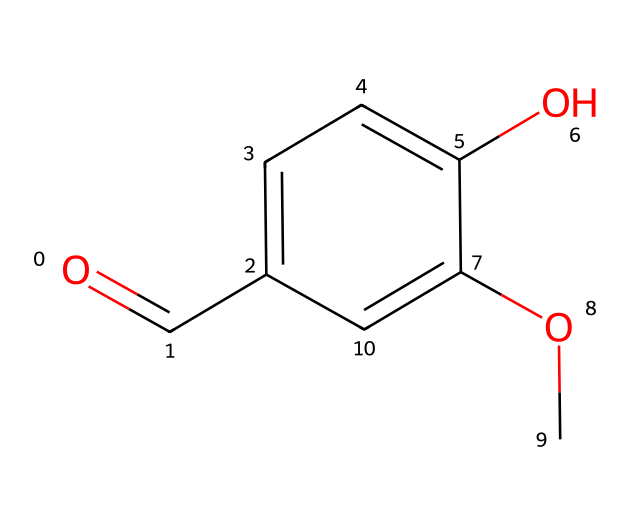What is the name of this chemical? The chemical structure provided represents vanillin, which is a compound commonly associated with the flavor of vanilla. The combination of carbon, oxygen, and hydroxyl functional groups is characteristic of vanillin.
Answer: vanillin How many carbon atoms are in vanillin? By analyzing the SMILES representation, we can count the number of carbon atoms. The structure shows six carbon atoms in the aromatic ring and the carbonyl carbon, totaling seven.
Answer: 7 What functional groups are present in vanillin? In the provided structure, the key functional groups are an aldehyde group (O=C), a hydroxyl group (–OH), and a methoxy group (–OCH3). These groups define its properties and flavor profile.
Answer: aldehyde, hydroxyl, methoxy What is the molecular formula of vanillin? From the SMILES representation, we can deduce the molecular formula by counting the atoms: 8 carbons, 8 hydrogens, and 3 oxygens give us C8H8O3 as the molecular formula.
Answer: C8H8O3 Does vanillin have a sweet or bitter taste? Vanillin is primarily known for its sweet and creamy flavor, commonly associated with desserts and sweetened beverages. This is due to its specific chemical structure, which interacts with taste receptors for sweetness.
Answer: sweet How does the presence of the methoxy group affect the aroma of vanillin? The methoxy group enhances the sweetness and depth of the aroma profile of vanillin, as it influences the volatility of the compound and its binding to olfactory receptors, contributing to a richer scent.
Answer: enhances aroma What type of compound is vanillin classified as? Vanillin is classified as a phenolic compound due to the presence of the aromatic ring and hydroxyl group, which contribute significantly to its flavor and fragrance properties in various beverages and foods.
Answer: phenolic compound 